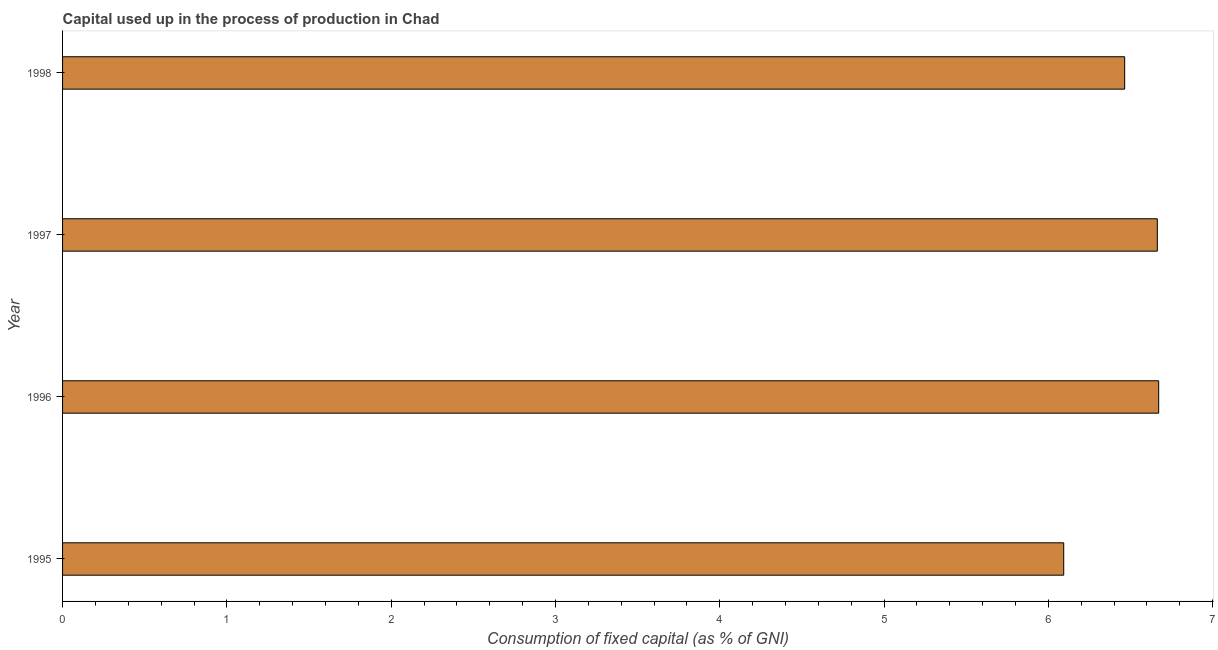What is the title of the graph?
Provide a succinct answer. Capital used up in the process of production in Chad. What is the label or title of the X-axis?
Your response must be concise. Consumption of fixed capital (as % of GNI). What is the consumption of fixed capital in 1997?
Keep it short and to the point. 6.66. Across all years, what is the maximum consumption of fixed capital?
Offer a terse response. 6.67. Across all years, what is the minimum consumption of fixed capital?
Your response must be concise. 6.09. In which year was the consumption of fixed capital maximum?
Keep it short and to the point. 1996. What is the sum of the consumption of fixed capital?
Your response must be concise. 25.89. What is the difference between the consumption of fixed capital in 1996 and 1998?
Your answer should be compact. 0.21. What is the average consumption of fixed capital per year?
Your response must be concise. 6.47. What is the median consumption of fixed capital?
Ensure brevity in your answer.  6.56. What is the ratio of the consumption of fixed capital in 1996 to that in 1997?
Your answer should be compact. 1. Is the consumption of fixed capital in 1996 less than that in 1997?
Provide a succinct answer. No. What is the difference between the highest and the second highest consumption of fixed capital?
Your answer should be compact. 0.01. What is the difference between the highest and the lowest consumption of fixed capital?
Provide a short and direct response. 0.58. In how many years, is the consumption of fixed capital greater than the average consumption of fixed capital taken over all years?
Ensure brevity in your answer.  2. How many years are there in the graph?
Provide a succinct answer. 4. Are the values on the major ticks of X-axis written in scientific E-notation?
Your answer should be compact. No. What is the Consumption of fixed capital (as % of GNI) of 1995?
Make the answer very short. 6.09. What is the Consumption of fixed capital (as % of GNI) of 1996?
Your answer should be compact. 6.67. What is the Consumption of fixed capital (as % of GNI) of 1997?
Ensure brevity in your answer.  6.66. What is the Consumption of fixed capital (as % of GNI) of 1998?
Make the answer very short. 6.46. What is the difference between the Consumption of fixed capital (as % of GNI) in 1995 and 1996?
Keep it short and to the point. -0.58. What is the difference between the Consumption of fixed capital (as % of GNI) in 1995 and 1997?
Offer a very short reply. -0.57. What is the difference between the Consumption of fixed capital (as % of GNI) in 1995 and 1998?
Ensure brevity in your answer.  -0.37. What is the difference between the Consumption of fixed capital (as % of GNI) in 1996 and 1997?
Provide a succinct answer. 0.01. What is the difference between the Consumption of fixed capital (as % of GNI) in 1996 and 1998?
Your response must be concise. 0.21. What is the difference between the Consumption of fixed capital (as % of GNI) in 1997 and 1998?
Provide a short and direct response. 0.2. What is the ratio of the Consumption of fixed capital (as % of GNI) in 1995 to that in 1997?
Provide a short and direct response. 0.91. What is the ratio of the Consumption of fixed capital (as % of GNI) in 1995 to that in 1998?
Offer a very short reply. 0.94. What is the ratio of the Consumption of fixed capital (as % of GNI) in 1996 to that in 1997?
Your response must be concise. 1. What is the ratio of the Consumption of fixed capital (as % of GNI) in 1996 to that in 1998?
Ensure brevity in your answer.  1.03. What is the ratio of the Consumption of fixed capital (as % of GNI) in 1997 to that in 1998?
Your answer should be compact. 1.03. 